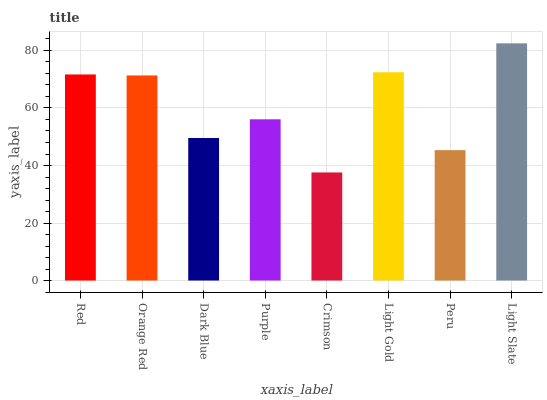Is Crimson the minimum?
Answer yes or no. Yes. Is Light Slate the maximum?
Answer yes or no. Yes. Is Orange Red the minimum?
Answer yes or no. No. Is Orange Red the maximum?
Answer yes or no. No. Is Red greater than Orange Red?
Answer yes or no. Yes. Is Orange Red less than Red?
Answer yes or no. Yes. Is Orange Red greater than Red?
Answer yes or no. No. Is Red less than Orange Red?
Answer yes or no. No. Is Orange Red the high median?
Answer yes or no. Yes. Is Purple the low median?
Answer yes or no. Yes. Is Light Gold the high median?
Answer yes or no. No. Is Peru the low median?
Answer yes or no. No. 